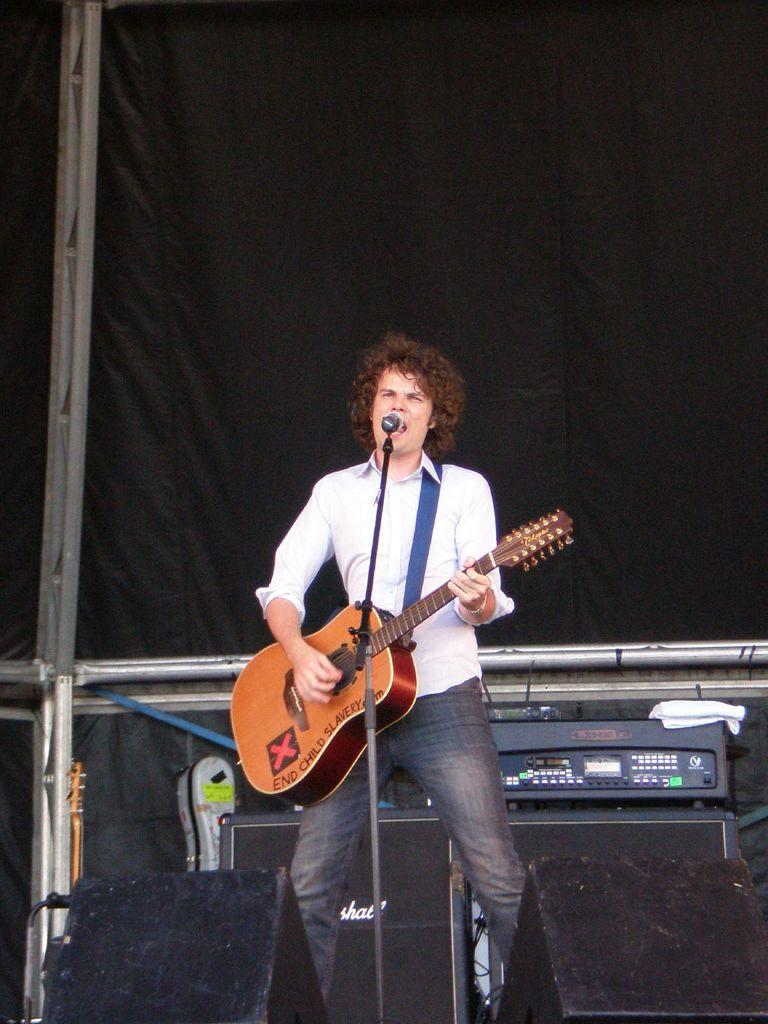What is the man in the image doing? The man is holding a guitar and singing a song. What object is in front of the man? There is a microphone with a stand in front of the man. What can be seen in the background of the image? The background of the image includes music instruments and a black cloth. What type of dust can be seen settling on the zinc in the image? There is no dust or zinc present in the image. How does the sand affect the sound of the guitar in the image? There is no sand present in the image, and therefore it cannot affect the sound of the guitar. 